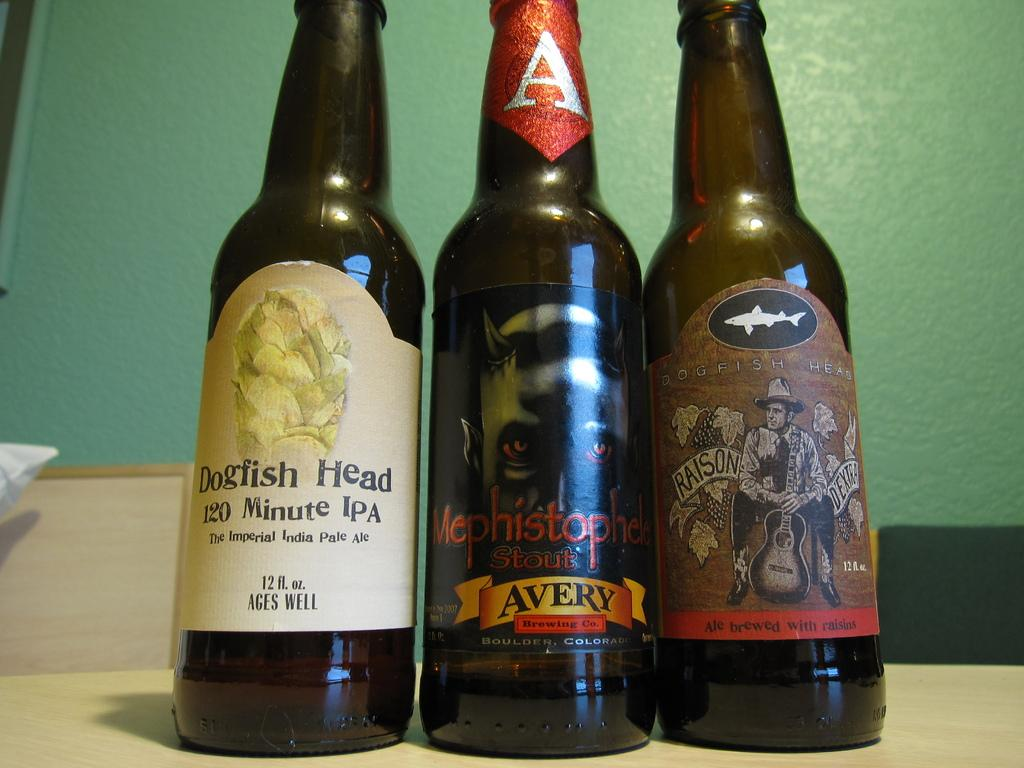<image>
Summarize the visual content of the image. Three bottles of beer, with labels displaying brand names such as Dogfish Head, are lined up on a counter in front of a green wall. 